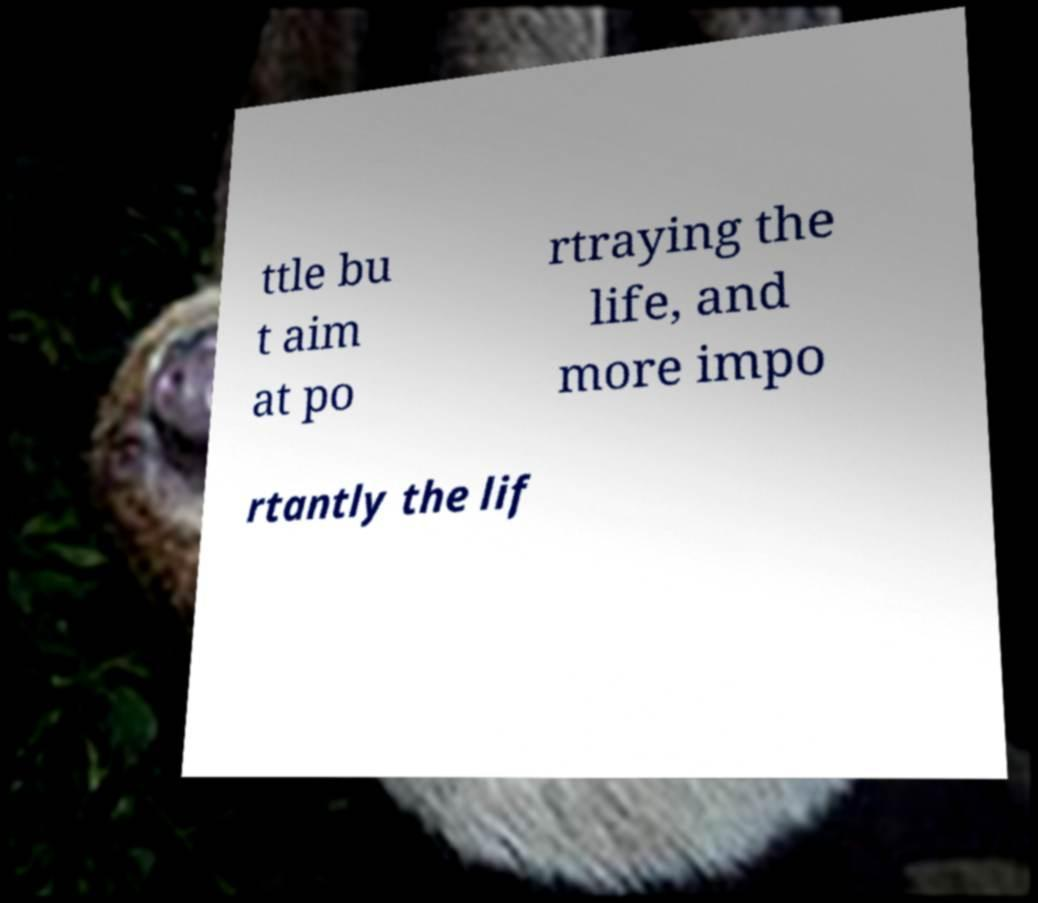Please identify and transcribe the text found in this image. ttle bu t aim at po rtraying the life, and more impo rtantly the lif 